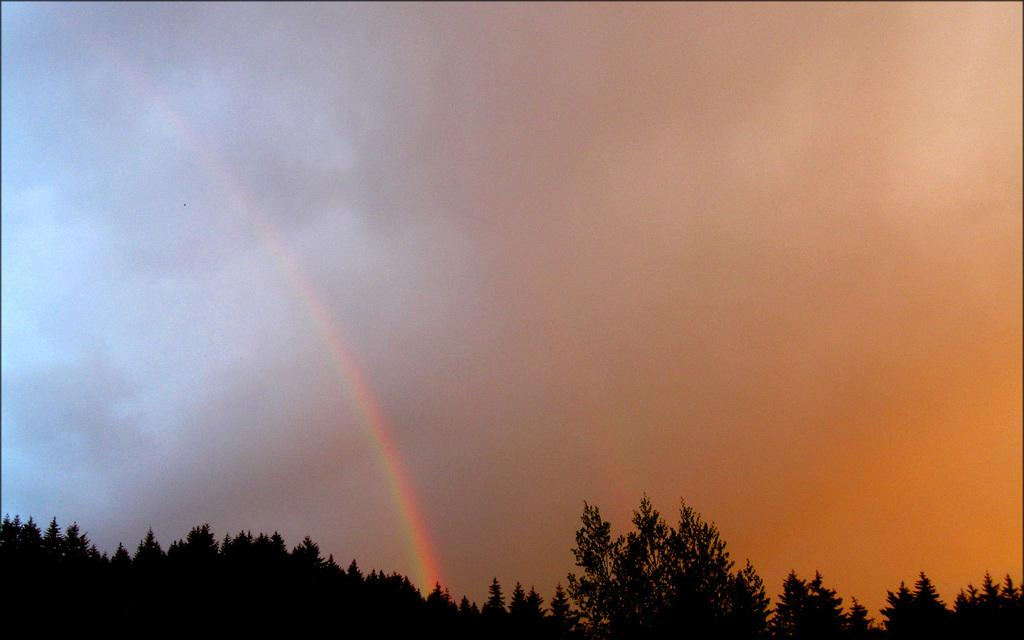What type of vegetation can be seen in the image? There are trees in the image. What natural phenomenon is visible in the sky? There is a rainbow visible in the sky. Where is the store located in the image? There is no store present in the image. What type of sofa can be seen in the image? There is no sofa present in the image. 